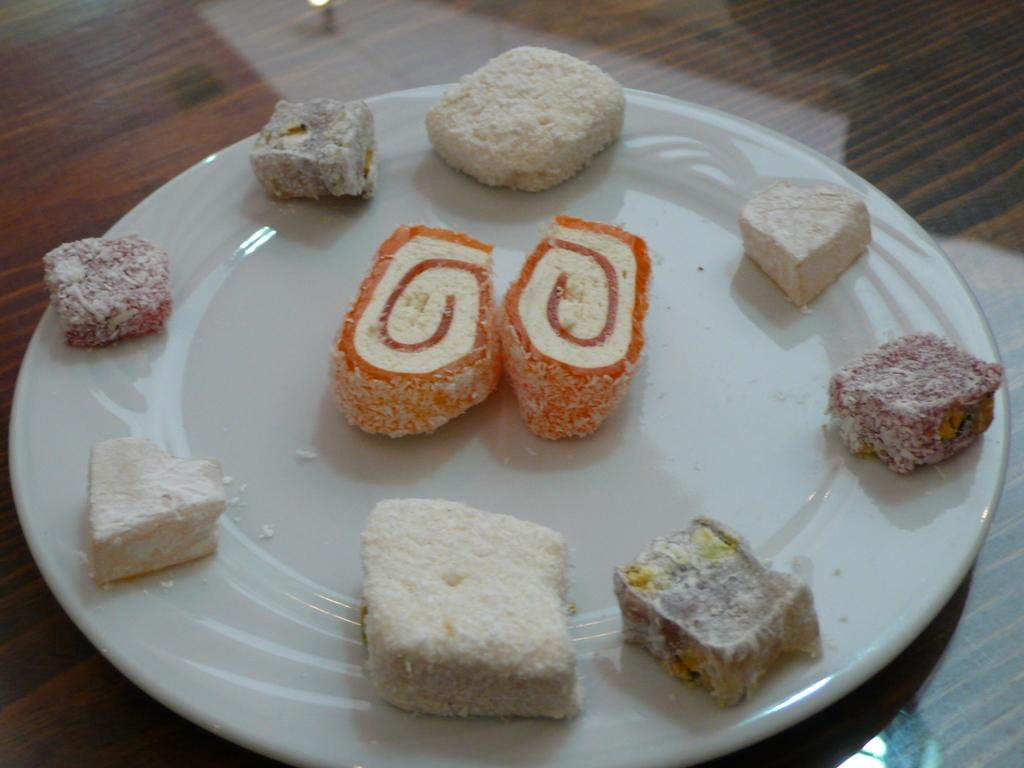What type of items can be seen in the image? There are eatables in the image. How are the eatables arranged or presented? The eatables are placed on a white plate. What is the role of the secretary in the image? There is no secretary present in the image; it only features eatables on a white plate. 